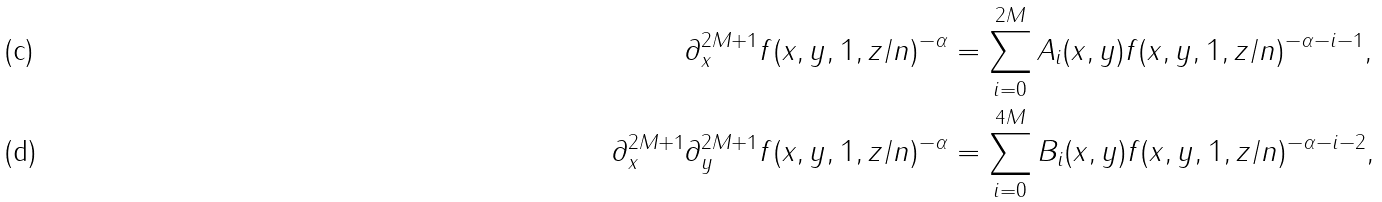Convert formula to latex. <formula><loc_0><loc_0><loc_500><loc_500>\partial _ { x } ^ { 2 M + 1 } f ( x , y , 1 , z / n ) ^ { - \alpha } & = \sum _ { i = 0 } ^ { 2 M } A _ { i } ( x , y ) f ( x , y , 1 , z / n ) ^ { - \alpha - i - 1 } , \\ \partial _ { x } ^ { 2 M + 1 } \partial _ { y } ^ { 2 M + 1 } f ( x , y , 1 , z / n ) ^ { - \alpha } & = \sum _ { i = 0 } ^ { 4 M } B _ { i } ( x , y ) f ( x , y , 1 , z / n ) ^ { - \alpha - i - 2 } ,</formula> 